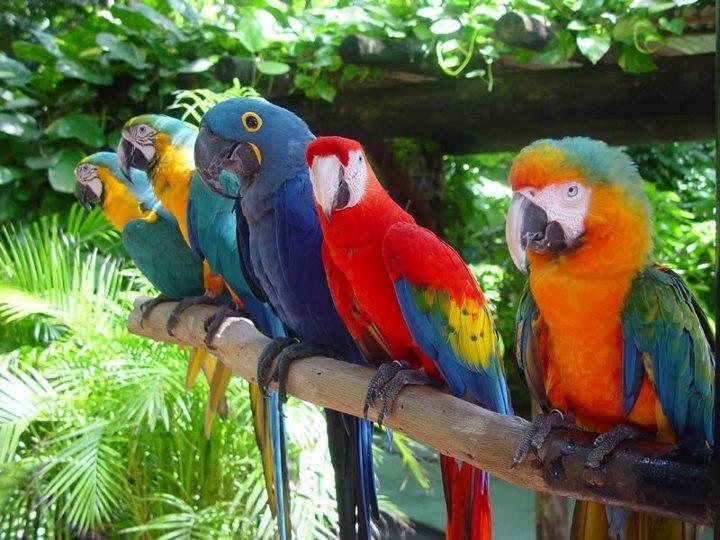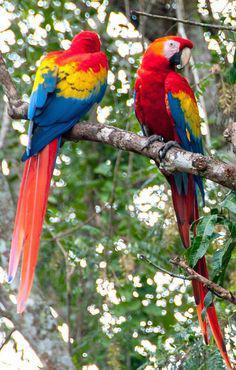The first image is the image on the left, the second image is the image on the right. Considering the images on both sides, is "One of the images contains exactly one parrot." valid? Answer yes or no. No. 